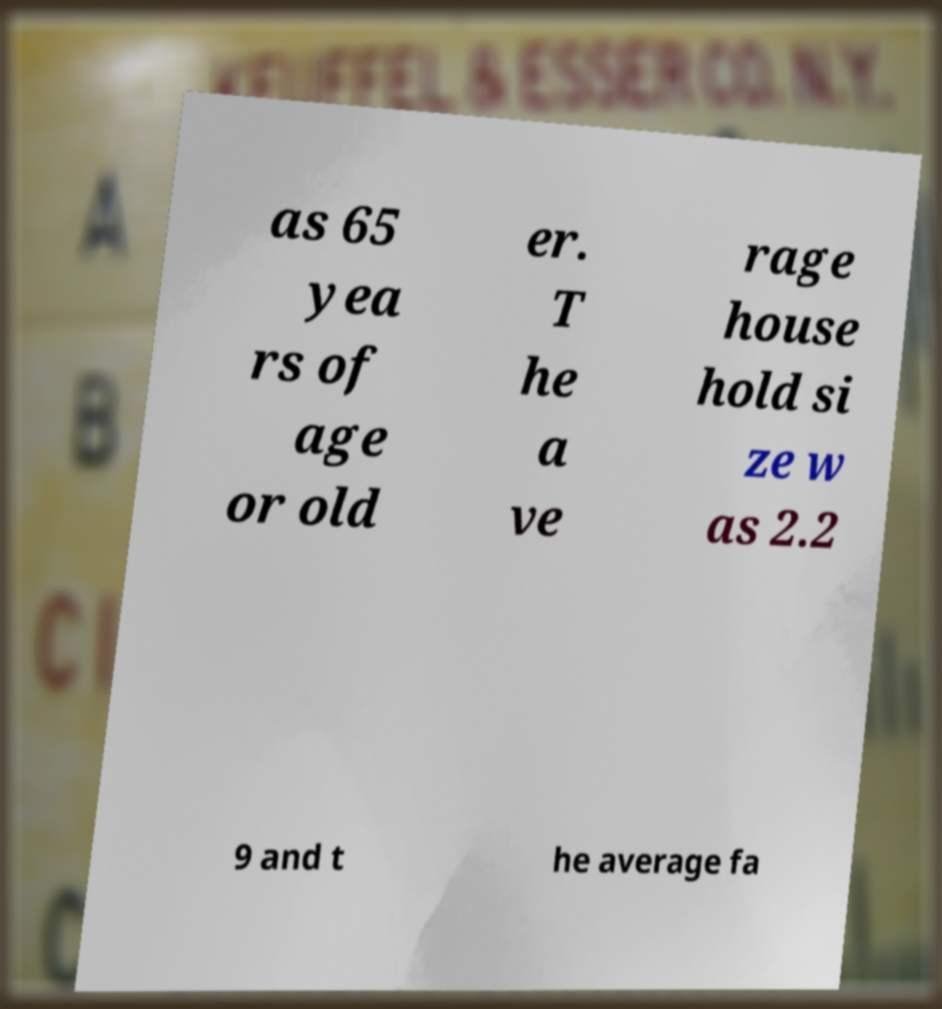Please identify and transcribe the text found in this image. as 65 yea rs of age or old er. T he a ve rage house hold si ze w as 2.2 9 and t he average fa 